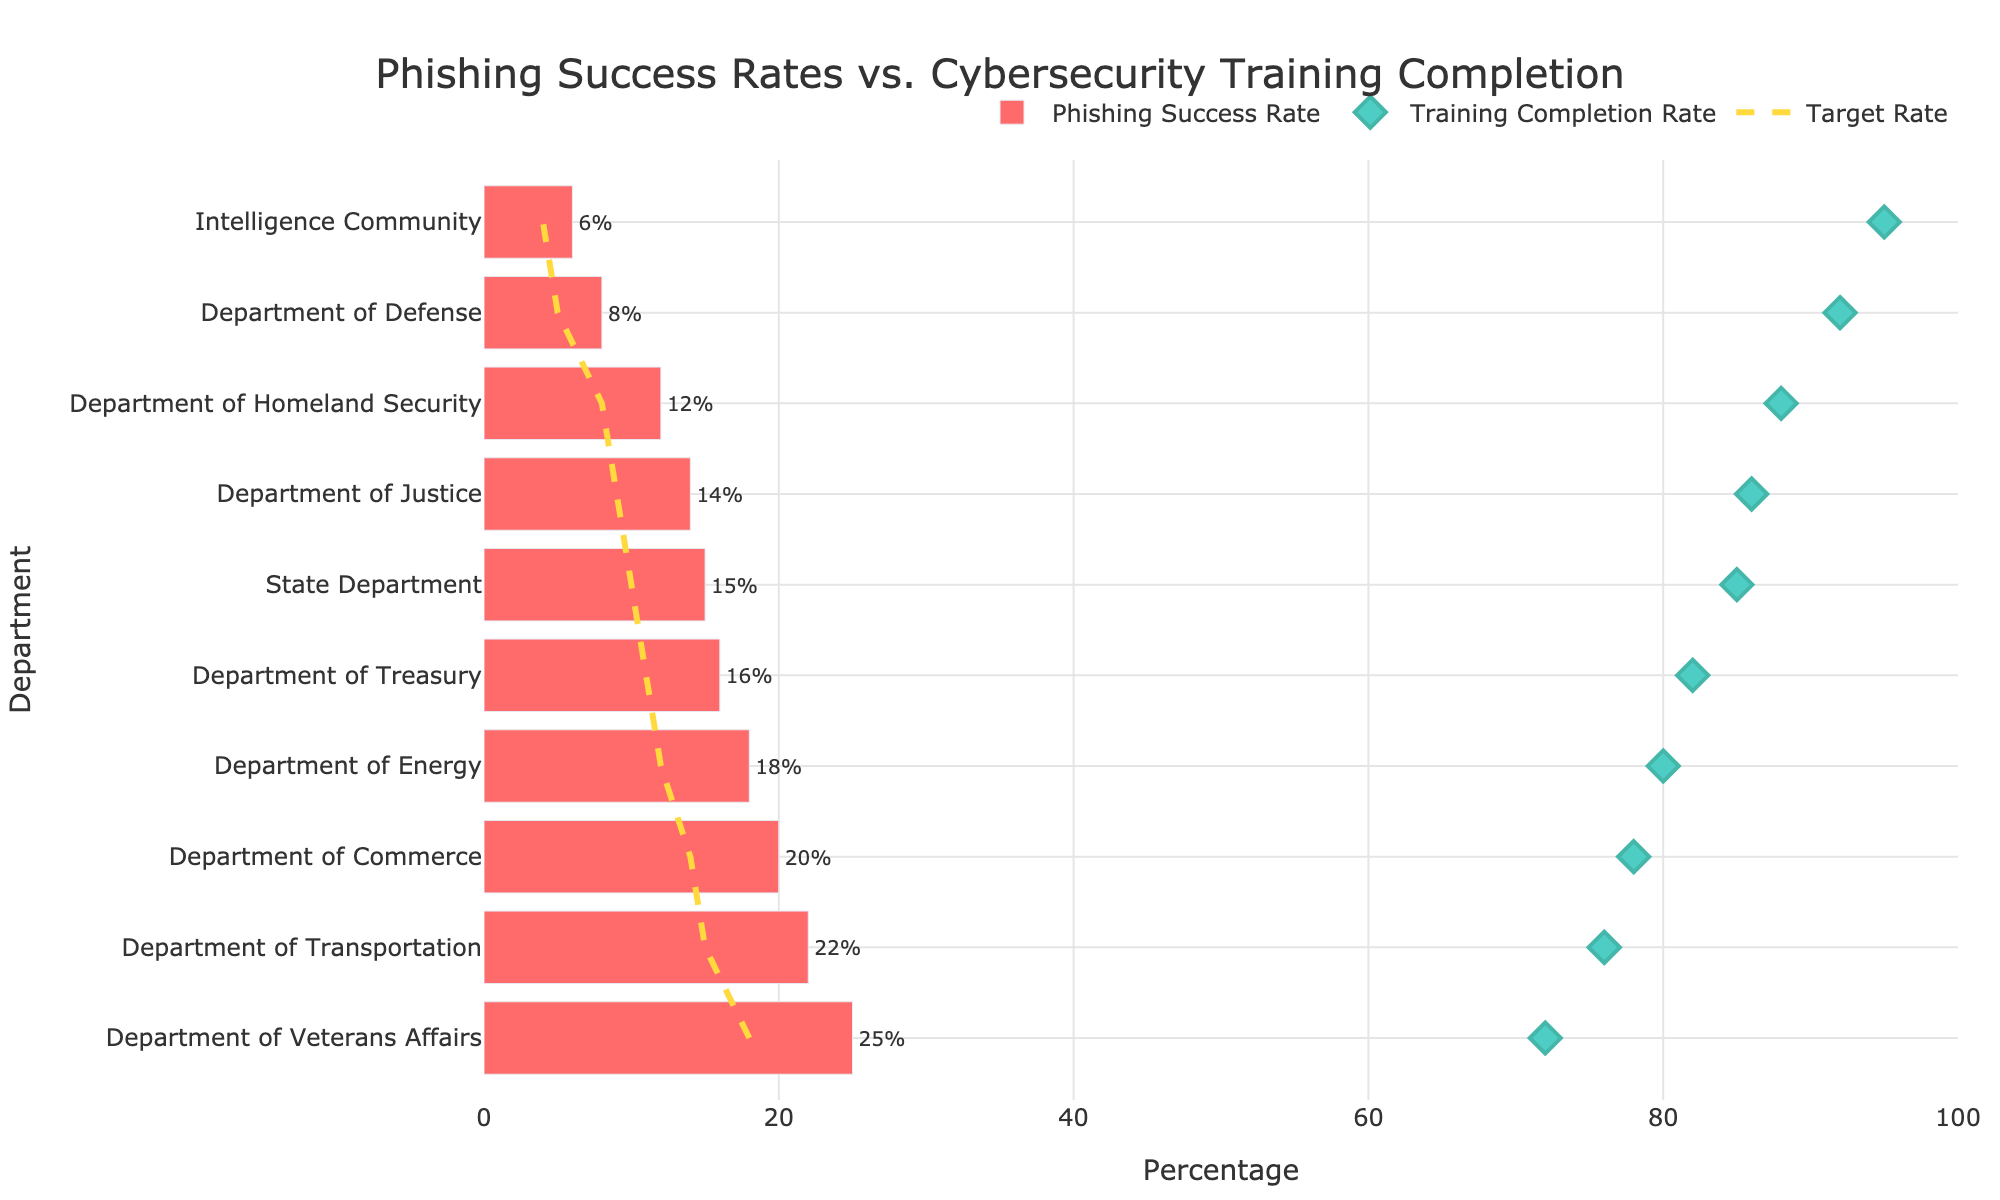What's the title of the figure? The title is placed at the top of the figure and is displayed prominently. It provides an overview of what the figure represents. The title reads "Phishing Success Rates vs. Cybersecurity Training Completion".
Answer: Phishing Success Rates vs. Cybersecurity Training Completion What is the Phishing Success Rate for the Department of Veterans Affairs? Locate the bar corresponding to the Department of Veterans Affairs on the figure. The text next to the bar indicates its Phishing Success Rate is 25%.
Answer: 25% What department has the highest Training Completion Rate? Identify the department with the highest marker on the Training Completion Rate axis. The highest Training Completion Rate is for the Intelligence Community at 95%.
Answer: Intelligence Community How does the Department of Commerce's Phishing Success Rate compare to its Target Rate? Find the bar and line corresponding to the Department of Commerce. The Phishing Success Rate is 20%, while the Target Rate is 14%. So, the Phishing Success Rate is 6 percentage points higher than the Target Rate.
Answer: 6 percentage points higher Which department needs to improve its cybersecurity training completion most urgently? Look for the department with the highest Phishing Success Rate and compare it with its Training Completion Rate and Target Rate. The Department of Veterans Affairs has the highest Phishing Success Rate of 25% and a lower Training Completion Rate of 72%. Hence, it requires the most urgent improvement.
Answer: Department of Veterans Affairs What is the difference between the highest and lowest Phishing Success Rates? Identify the highest and lowest Phishing Success Rates from the bars, which are for the Department of Veterans Affairs (25%) and the Intelligence Community (6%) respectively. Calculate the difference: 25% - 6% = 19%.
Answer: 19% Which department's Phishing Success Rate is closest to its Target Rate? Compare the bars and lines for all departments. The Department of Homeland Security has a Phishing Success Rate of 12% and a Target Rate of 8%, which is a difference of 4 percentage points, the smallest among all departments.
Answer: Department of Homeland Security What is the average Phishing Success Rate across all departments? Add all the Phishing Success Rates and divide by the number of departments. Sum: 15% + 8% + 12% + 18% + 6% + 14% + 16% + 20% + 22% + 25% = 156%. Number of departments: 10. Average = 156% / 10 = 15.6%.
Answer: 15.6% Is there a correlation between high Training Completion Rates and low Phishing Success Rates? Compare the departments with high Training Completion Rates (above 85%) and see if their Phishing Success Rates are generally low. Departments like the Intelligence Community and the Department of Defense show high Training Completion Rates and lower Phishing Success Rates, indicating a negative correlation.
Answer: Yes Which department's Phishing Success Rate exceeds its Target Rate by the largest margin? Find the department with the highest difference between its Phishing Success Rate and Target Rate. The Department of Transportation's Phishing Success Rate is 22%, and its Target Rate is 15%, resulting in a 7 percentage point difference, the largest among all departments.
Answer: Department of Transportation 